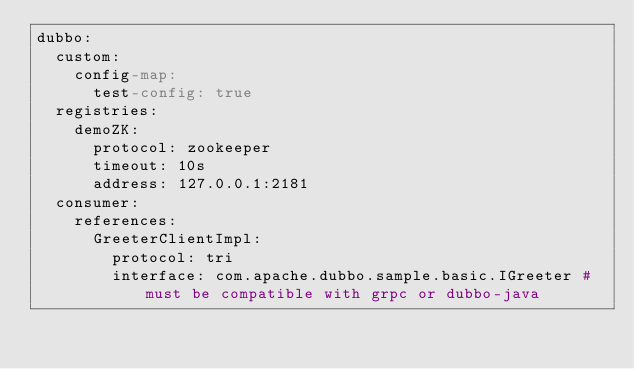Convert code to text. <code><loc_0><loc_0><loc_500><loc_500><_YAML_>dubbo:
  custom:
    config-map:
      test-config: true
  registries:
    demoZK:
      protocol: zookeeper
      timeout: 10s
      address: 127.0.0.1:2181
  consumer:
    references:
      GreeterClientImpl:
        protocol: tri
        interface: com.apache.dubbo.sample.basic.IGreeter # must be compatible with grpc or dubbo-java</code> 